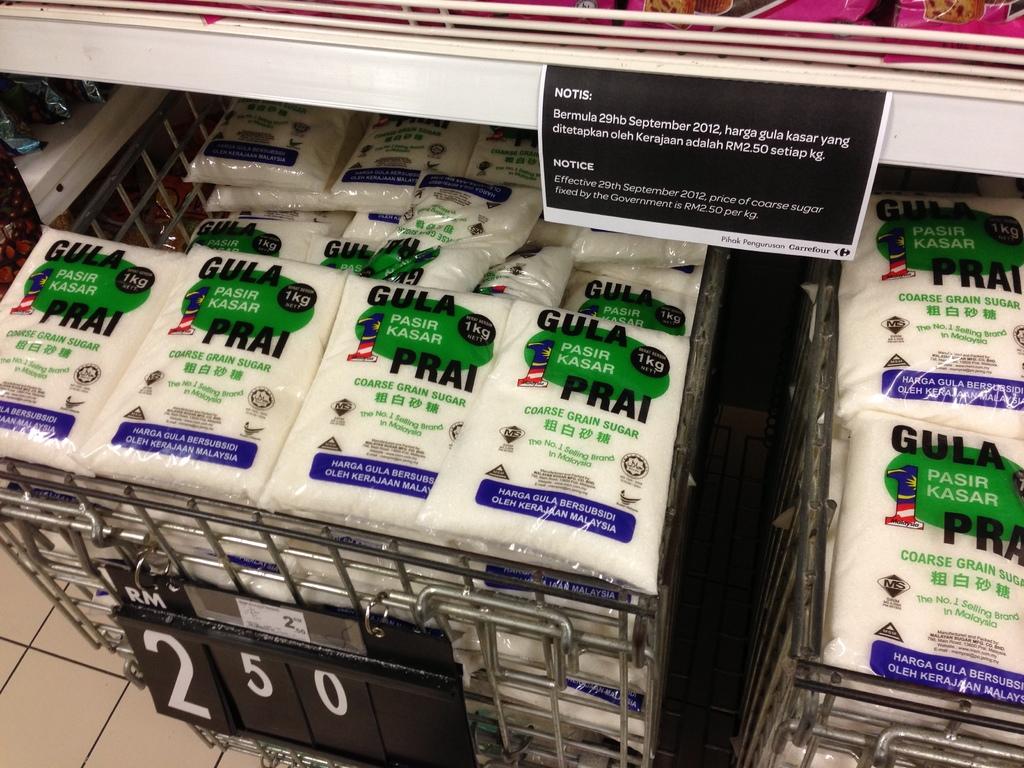How much is the gula prai?
Provide a short and direct response. 2.50. What is gula prai?
Your answer should be compact. Coarse grain sugar. 